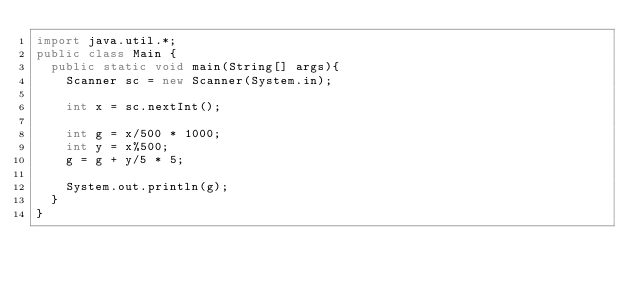Convert code to text. <code><loc_0><loc_0><loc_500><loc_500><_Java_>import java.util.*;
public class Main {
	public static void main(String[] args){
		Scanner sc = new Scanner(System.in);

		int x = sc.nextInt();

		int g = x/500 * 1000;
		int y = x%500;
		g = g + y/5 * 5;

		System.out.println(g);
	}
}</code> 